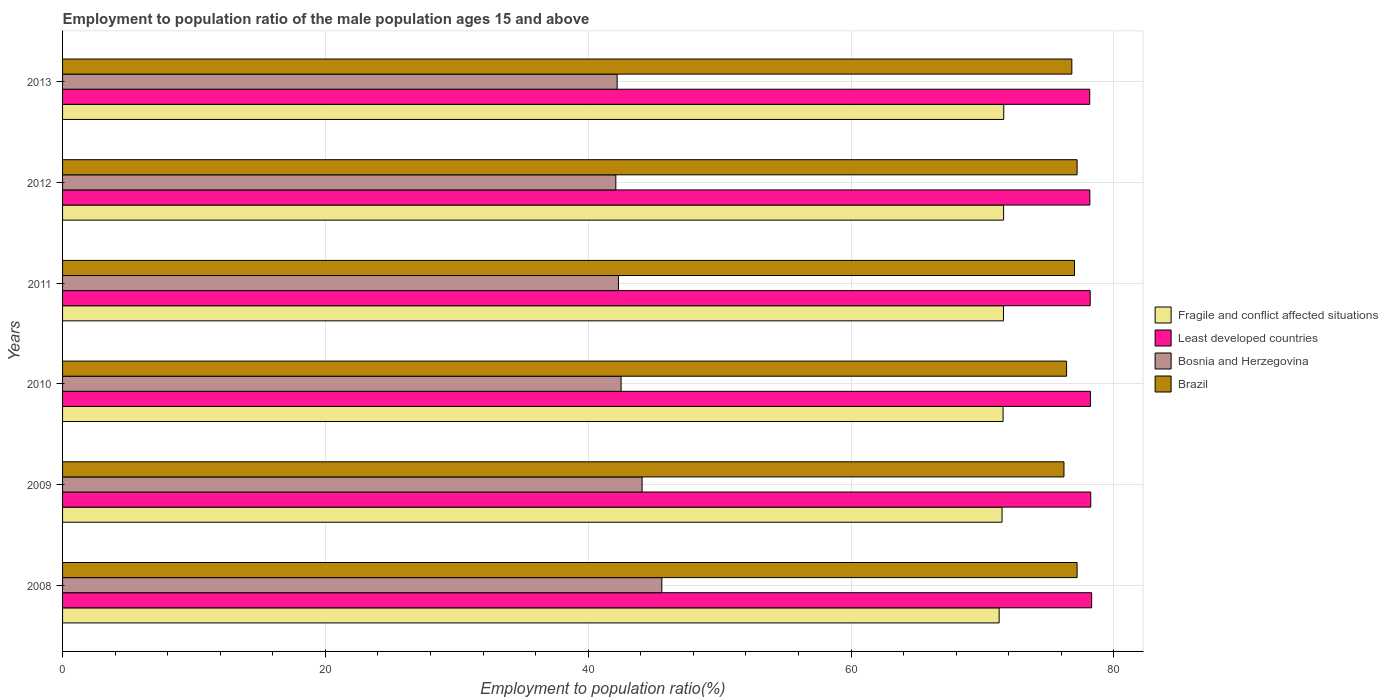How many groups of bars are there?
Provide a short and direct response. 6. Are the number of bars per tick equal to the number of legend labels?
Provide a short and direct response. Yes. Are the number of bars on each tick of the Y-axis equal?
Make the answer very short. Yes. What is the label of the 6th group of bars from the top?
Ensure brevity in your answer.  2008. What is the employment to population ratio in Bosnia and Herzegovina in 2012?
Your answer should be compact. 42.1. Across all years, what is the maximum employment to population ratio in Brazil?
Provide a short and direct response. 77.2. Across all years, what is the minimum employment to population ratio in Fragile and conflict affected situations?
Keep it short and to the point. 71.27. What is the total employment to population ratio in Fragile and conflict affected situations in the graph?
Ensure brevity in your answer.  429.14. What is the difference between the employment to population ratio in Least developed countries in 2011 and that in 2012?
Your answer should be compact. 0.03. What is the difference between the employment to population ratio in Bosnia and Herzegovina in 2010 and the employment to population ratio in Fragile and conflict affected situations in 2011?
Offer a very short reply. -29.1. What is the average employment to population ratio in Bosnia and Herzegovina per year?
Your response must be concise. 43.13. In the year 2013, what is the difference between the employment to population ratio in Brazil and employment to population ratio in Least developed countries?
Your answer should be very brief. -1.36. In how many years, is the employment to population ratio in Brazil greater than 44 %?
Your answer should be very brief. 6. What is the ratio of the employment to population ratio in Fragile and conflict affected situations in 2010 to that in 2012?
Offer a very short reply. 1. Is the employment to population ratio in Fragile and conflict affected situations in 2009 less than that in 2010?
Give a very brief answer. Yes. What is the difference between the highest and the second highest employment to population ratio in Brazil?
Ensure brevity in your answer.  0. Is it the case that in every year, the sum of the employment to population ratio in Brazil and employment to population ratio in Bosnia and Herzegovina is greater than the sum of employment to population ratio in Fragile and conflict affected situations and employment to population ratio in Least developed countries?
Your response must be concise. No. What does the 4th bar from the top in 2013 represents?
Ensure brevity in your answer.  Fragile and conflict affected situations. Is it the case that in every year, the sum of the employment to population ratio in Least developed countries and employment to population ratio in Brazil is greater than the employment to population ratio in Bosnia and Herzegovina?
Your answer should be very brief. Yes. How many bars are there?
Your response must be concise. 24. Are all the bars in the graph horizontal?
Ensure brevity in your answer.  Yes. How many years are there in the graph?
Give a very brief answer. 6. What is the difference between two consecutive major ticks on the X-axis?
Ensure brevity in your answer.  20. Are the values on the major ticks of X-axis written in scientific E-notation?
Provide a succinct answer. No. How many legend labels are there?
Your response must be concise. 4. How are the legend labels stacked?
Provide a short and direct response. Vertical. What is the title of the graph?
Give a very brief answer. Employment to population ratio of the male population ages 15 and above. What is the label or title of the X-axis?
Your answer should be very brief. Employment to population ratio(%). What is the label or title of the Y-axis?
Offer a very short reply. Years. What is the Employment to population ratio(%) of Fragile and conflict affected situations in 2008?
Your answer should be very brief. 71.27. What is the Employment to population ratio(%) of Least developed countries in 2008?
Your answer should be compact. 78.31. What is the Employment to population ratio(%) of Bosnia and Herzegovina in 2008?
Give a very brief answer. 45.6. What is the Employment to population ratio(%) in Brazil in 2008?
Make the answer very short. 77.2. What is the Employment to population ratio(%) of Fragile and conflict affected situations in 2009?
Keep it short and to the point. 71.49. What is the Employment to population ratio(%) in Least developed countries in 2009?
Provide a succinct answer. 78.24. What is the Employment to population ratio(%) of Bosnia and Herzegovina in 2009?
Provide a short and direct response. 44.1. What is the Employment to population ratio(%) of Brazil in 2009?
Give a very brief answer. 76.2. What is the Employment to population ratio(%) of Fragile and conflict affected situations in 2010?
Give a very brief answer. 71.57. What is the Employment to population ratio(%) in Least developed countries in 2010?
Provide a short and direct response. 78.22. What is the Employment to population ratio(%) in Bosnia and Herzegovina in 2010?
Ensure brevity in your answer.  42.5. What is the Employment to population ratio(%) of Brazil in 2010?
Offer a very short reply. 76.4. What is the Employment to population ratio(%) of Fragile and conflict affected situations in 2011?
Provide a succinct answer. 71.6. What is the Employment to population ratio(%) in Least developed countries in 2011?
Provide a short and direct response. 78.2. What is the Employment to population ratio(%) of Bosnia and Herzegovina in 2011?
Offer a very short reply. 42.3. What is the Employment to population ratio(%) in Brazil in 2011?
Provide a succinct answer. 77. What is the Employment to population ratio(%) of Fragile and conflict affected situations in 2012?
Provide a succinct answer. 71.61. What is the Employment to population ratio(%) of Least developed countries in 2012?
Provide a succinct answer. 78.17. What is the Employment to population ratio(%) of Bosnia and Herzegovina in 2012?
Provide a short and direct response. 42.1. What is the Employment to population ratio(%) in Brazil in 2012?
Provide a short and direct response. 77.2. What is the Employment to population ratio(%) of Fragile and conflict affected situations in 2013?
Offer a terse response. 71.62. What is the Employment to population ratio(%) of Least developed countries in 2013?
Provide a short and direct response. 78.16. What is the Employment to population ratio(%) of Bosnia and Herzegovina in 2013?
Your response must be concise. 42.2. What is the Employment to population ratio(%) of Brazil in 2013?
Ensure brevity in your answer.  76.8. Across all years, what is the maximum Employment to population ratio(%) in Fragile and conflict affected situations?
Provide a succinct answer. 71.62. Across all years, what is the maximum Employment to population ratio(%) of Least developed countries?
Ensure brevity in your answer.  78.31. Across all years, what is the maximum Employment to population ratio(%) in Bosnia and Herzegovina?
Offer a terse response. 45.6. Across all years, what is the maximum Employment to population ratio(%) of Brazil?
Give a very brief answer. 77.2. Across all years, what is the minimum Employment to population ratio(%) in Fragile and conflict affected situations?
Make the answer very short. 71.27. Across all years, what is the minimum Employment to population ratio(%) in Least developed countries?
Your answer should be very brief. 78.16. Across all years, what is the minimum Employment to population ratio(%) in Bosnia and Herzegovina?
Ensure brevity in your answer.  42.1. Across all years, what is the minimum Employment to population ratio(%) of Brazil?
Provide a short and direct response. 76.2. What is the total Employment to population ratio(%) in Fragile and conflict affected situations in the graph?
Provide a short and direct response. 429.14. What is the total Employment to population ratio(%) of Least developed countries in the graph?
Give a very brief answer. 469.29. What is the total Employment to population ratio(%) of Bosnia and Herzegovina in the graph?
Offer a very short reply. 258.8. What is the total Employment to population ratio(%) in Brazil in the graph?
Keep it short and to the point. 460.8. What is the difference between the Employment to population ratio(%) in Fragile and conflict affected situations in 2008 and that in 2009?
Provide a succinct answer. -0.22. What is the difference between the Employment to population ratio(%) in Least developed countries in 2008 and that in 2009?
Ensure brevity in your answer.  0.07. What is the difference between the Employment to population ratio(%) of Bosnia and Herzegovina in 2008 and that in 2009?
Offer a terse response. 1.5. What is the difference between the Employment to population ratio(%) in Brazil in 2008 and that in 2009?
Your answer should be very brief. 1. What is the difference between the Employment to population ratio(%) in Fragile and conflict affected situations in 2008 and that in 2010?
Your response must be concise. -0.3. What is the difference between the Employment to population ratio(%) in Least developed countries in 2008 and that in 2010?
Your answer should be very brief. 0.09. What is the difference between the Employment to population ratio(%) in Bosnia and Herzegovina in 2008 and that in 2010?
Offer a terse response. 3.1. What is the difference between the Employment to population ratio(%) of Brazil in 2008 and that in 2010?
Your answer should be compact. 0.8. What is the difference between the Employment to population ratio(%) in Fragile and conflict affected situations in 2008 and that in 2011?
Provide a succinct answer. -0.33. What is the difference between the Employment to population ratio(%) of Least developed countries in 2008 and that in 2011?
Your answer should be very brief. 0.11. What is the difference between the Employment to population ratio(%) of Brazil in 2008 and that in 2011?
Your response must be concise. 0.2. What is the difference between the Employment to population ratio(%) in Fragile and conflict affected situations in 2008 and that in 2012?
Ensure brevity in your answer.  -0.34. What is the difference between the Employment to population ratio(%) in Least developed countries in 2008 and that in 2012?
Ensure brevity in your answer.  0.14. What is the difference between the Employment to population ratio(%) of Bosnia and Herzegovina in 2008 and that in 2012?
Give a very brief answer. 3.5. What is the difference between the Employment to population ratio(%) in Brazil in 2008 and that in 2012?
Make the answer very short. 0. What is the difference between the Employment to population ratio(%) in Fragile and conflict affected situations in 2008 and that in 2013?
Ensure brevity in your answer.  -0.35. What is the difference between the Employment to population ratio(%) of Least developed countries in 2008 and that in 2013?
Give a very brief answer. 0.15. What is the difference between the Employment to population ratio(%) in Brazil in 2008 and that in 2013?
Your answer should be very brief. 0.4. What is the difference between the Employment to population ratio(%) in Fragile and conflict affected situations in 2009 and that in 2010?
Your answer should be compact. -0.08. What is the difference between the Employment to population ratio(%) of Least developed countries in 2009 and that in 2010?
Ensure brevity in your answer.  0.02. What is the difference between the Employment to population ratio(%) in Bosnia and Herzegovina in 2009 and that in 2010?
Your answer should be very brief. 1.6. What is the difference between the Employment to population ratio(%) of Fragile and conflict affected situations in 2009 and that in 2011?
Provide a short and direct response. -0.11. What is the difference between the Employment to population ratio(%) of Least developed countries in 2009 and that in 2011?
Provide a short and direct response. 0.04. What is the difference between the Employment to population ratio(%) of Bosnia and Herzegovina in 2009 and that in 2011?
Offer a very short reply. 1.8. What is the difference between the Employment to population ratio(%) in Fragile and conflict affected situations in 2009 and that in 2012?
Offer a very short reply. -0.12. What is the difference between the Employment to population ratio(%) in Least developed countries in 2009 and that in 2012?
Offer a terse response. 0.07. What is the difference between the Employment to population ratio(%) of Bosnia and Herzegovina in 2009 and that in 2012?
Make the answer very short. 2. What is the difference between the Employment to population ratio(%) of Fragile and conflict affected situations in 2009 and that in 2013?
Provide a succinct answer. -0.13. What is the difference between the Employment to population ratio(%) of Least developed countries in 2009 and that in 2013?
Give a very brief answer. 0.08. What is the difference between the Employment to population ratio(%) of Bosnia and Herzegovina in 2009 and that in 2013?
Offer a very short reply. 1.9. What is the difference between the Employment to population ratio(%) of Brazil in 2009 and that in 2013?
Make the answer very short. -0.6. What is the difference between the Employment to population ratio(%) in Fragile and conflict affected situations in 2010 and that in 2011?
Give a very brief answer. -0.03. What is the difference between the Employment to population ratio(%) of Least developed countries in 2010 and that in 2011?
Your answer should be very brief. 0.02. What is the difference between the Employment to population ratio(%) in Bosnia and Herzegovina in 2010 and that in 2011?
Ensure brevity in your answer.  0.2. What is the difference between the Employment to population ratio(%) of Brazil in 2010 and that in 2011?
Give a very brief answer. -0.6. What is the difference between the Employment to population ratio(%) of Fragile and conflict affected situations in 2010 and that in 2012?
Give a very brief answer. -0.04. What is the difference between the Employment to population ratio(%) in Least developed countries in 2010 and that in 2012?
Your answer should be very brief. 0.05. What is the difference between the Employment to population ratio(%) in Bosnia and Herzegovina in 2010 and that in 2012?
Your answer should be compact. 0.4. What is the difference between the Employment to population ratio(%) in Fragile and conflict affected situations in 2010 and that in 2013?
Your answer should be compact. -0.05. What is the difference between the Employment to population ratio(%) in Least developed countries in 2010 and that in 2013?
Provide a short and direct response. 0.06. What is the difference between the Employment to population ratio(%) in Bosnia and Herzegovina in 2010 and that in 2013?
Keep it short and to the point. 0.3. What is the difference between the Employment to population ratio(%) in Brazil in 2010 and that in 2013?
Give a very brief answer. -0.4. What is the difference between the Employment to population ratio(%) of Fragile and conflict affected situations in 2011 and that in 2012?
Offer a very short reply. -0.01. What is the difference between the Employment to population ratio(%) in Least developed countries in 2011 and that in 2012?
Your answer should be very brief. 0.03. What is the difference between the Employment to population ratio(%) of Bosnia and Herzegovina in 2011 and that in 2012?
Ensure brevity in your answer.  0.2. What is the difference between the Employment to population ratio(%) in Brazil in 2011 and that in 2012?
Ensure brevity in your answer.  -0.2. What is the difference between the Employment to population ratio(%) in Fragile and conflict affected situations in 2011 and that in 2013?
Provide a short and direct response. -0.02. What is the difference between the Employment to population ratio(%) of Least developed countries in 2011 and that in 2013?
Ensure brevity in your answer.  0.04. What is the difference between the Employment to population ratio(%) in Brazil in 2011 and that in 2013?
Provide a succinct answer. 0.2. What is the difference between the Employment to population ratio(%) in Fragile and conflict affected situations in 2012 and that in 2013?
Give a very brief answer. -0.01. What is the difference between the Employment to population ratio(%) of Least developed countries in 2012 and that in 2013?
Your answer should be very brief. 0.01. What is the difference between the Employment to population ratio(%) of Fragile and conflict affected situations in 2008 and the Employment to population ratio(%) of Least developed countries in 2009?
Keep it short and to the point. -6.97. What is the difference between the Employment to population ratio(%) of Fragile and conflict affected situations in 2008 and the Employment to population ratio(%) of Bosnia and Herzegovina in 2009?
Provide a succinct answer. 27.17. What is the difference between the Employment to population ratio(%) in Fragile and conflict affected situations in 2008 and the Employment to population ratio(%) in Brazil in 2009?
Your answer should be very brief. -4.93. What is the difference between the Employment to population ratio(%) of Least developed countries in 2008 and the Employment to population ratio(%) of Bosnia and Herzegovina in 2009?
Provide a succinct answer. 34.21. What is the difference between the Employment to population ratio(%) in Least developed countries in 2008 and the Employment to population ratio(%) in Brazil in 2009?
Keep it short and to the point. 2.11. What is the difference between the Employment to population ratio(%) of Bosnia and Herzegovina in 2008 and the Employment to population ratio(%) of Brazil in 2009?
Offer a terse response. -30.6. What is the difference between the Employment to population ratio(%) of Fragile and conflict affected situations in 2008 and the Employment to population ratio(%) of Least developed countries in 2010?
Keep it short and to the point. -6.95. What is the difference between the Employment to population ratio(%) in Fragile and conflict affected situations in 2008 and the Employment to population ratio(%) in Bosnia and Herzegovina in 2010?
Your response must be concise. 28.77. What is the difference between the Employment to population ratio(%) of Fragile and conflict affected situations in 2008 and the Employment to population ratio(%) of Brazil in 2010?
Your answer should be very brief. -5.13. What is the difference between the Employment to population ratio(%) of Least developed countries in 2008 and the Employment to population ratio(%) of Bosnia and Herzegovina in 2010?
Offer a terse response. 35.81. What is the difference between the Employment to population ratio(%) of Least developed countries in 2008 and the Employment to population ratio(%) of Brazil in 2010?
Your answer should be very brief. 1.91. What is the difference between the Employment to population ratio(%) in Bosnia and Herzegovina in 2008 and the Employment to population ratio(%) in Brazil in 2010?
Offer a terse response. -30.8. What is the difference between the Employment to population ratio(%) of Fragile and conflict affected situations in 2008 and the Employment to population ratio(%) of Least developed countries in 2011?
Keep it short and to the point. -6.93. What is the difference between the Employment to population ratio(%) in Fragile and conflict affected situations in 2008 and the Employment to population ratio(%) in Bosnia and Herzegovina in 2011?
Offer a terse response. 28.97. What is the difference between the Employment to population ratio(%) of Fragile and conflict affected situations in 2008 and the Employment to population ratio(%) of Brazil in 2011?
Keep it short and to the point. -5.73. What is the difference between the Employment to population ratio(%) of Least developed countries in 2008 and the Employment to population ratio(%) of Bosnia and Herzegovina in 2011?
Your response must be concise. 36.01. What is the difference between the Employment to population ratio(%) of Least developed countries in 2008 and the Employment to population ratio(%) of Brazil in 2011?
Your answer should be compact. 1.31. What is the difference between the Employment to population ratio(%) in Bosnia and Herzegovina in 2008 and the Employment to population ratio(%) in Brazil in 2011?
Make the answer very short. -31.4. What is the difference between the Employment to population ratio(%) of Fragile and conflict affected situations in 2008 and the Employment to population ratio(%) of Least developed countries in 2012?
Your answer should be very brief. -6.9. What is the difference between the Employment to population ratio(%) in Fragile and conflict affected situations in 2008 and the Employment to population ratio(%) in Bosnia and Herzegovina in 2012?
Offer a very short reply. 29.17. What is the difference between the Employment to population ratio(%) of Fragile and conflict affected situations in 2008 and the Employment to population ratio(%) of Brazil in 2012?
Ensure brevity in your answer.  -5.93. What is the difference between the Employment to population ratio(%) in Least developed countries in 2008 and the Employment to population ratio(%) in Bosnia and Herzegovina in 2012?
Provide a succinct answer. 36.21. What is the difference between the Employment to population ratio(%) of Least developed countries in 2008 and the Employment to population ratio(%) of Brazil in 2012?
Make the answer very short. 1.11. What is the difference between the Employment to population ratio(%) of Bosnia and Herzegovina in 2008 and the Employment to population ratio(%) of Brazil in 2012?
Provide a short and direct response. -31.6. What is the difference between the Employment to population ratio(%) of Fragile and conflict affected situations in 2008 and the Employment to population ratio(%) of Least developed countries in 2013?
Your answer should be very brief. -6.89. What is the difference between the Employment to population ratio(%) of Fragile and conflict affected situations in 2008 and the Employment to population ratio(%) of Bosnia and Herzegovina in 2013?
Provide a short and direct response. 29.07. What is the difference between the Employment to population ratio(%) of Fragile and conflict affected situations in 2008 and the Employment to population ratio(%) of Brazil in 2013?
Offer a terse response. -5.53. What is the difference between the Employment to population ratio(%) of Least developed countries in 2008 and the Employment to population ratio(%) of Bosnia and Herzegovina in 2013?
Your response must be concise. 36.11. What is the difference between the Employment to population ratio(%) in Least developed countries in 2008 and the Employment to population ratio(%) in Brazil in 2013?
Keep it short and to the point. 1.51. What is the difference between the Employment to population ratio(%) of Bosnia and Herzegovina in 2008 and the Employment to population ratio(%) of Brazil in 2013?
Offer a very short reply. -31.2. What is the difference between the Employment to population ratio(%) in Fragile and conflict affected situations in 2009 and the Employment to population ratio(%) in Least developed countries in 2010?
Your answer should be very brief. -6.73. What is the difference between the Employment to population ratio(%) of Fragile and conflict affected situations in 2009 and the Employment to population ratio(%) of Bosnia and Herzegovina in 2010?
Provide a short and direct response. 28.99. What is the difference between the Employment to population ratio(%) in Fragile and conflict affected situations in 2009 and the Employment to population ratio(%) in Brazil in 2010?
Your response must be concise. -4.91. What is the difference between the Employment to population ratio(%) in Least developed countries in 2009 and the Employment to population ratio(%) in Bosnia and Herzegovina in 2010?
Provide a short and direct response. 35.74. What is the difference between the Employment to population ratio(%) of Least developed countries in 2009 and the Employment to population ratio(%) of Brazil in 2010?
Offer a very short reply. 1.84. What is the difference between the Employment to population ratio(%) in Bosnia and Herzegovina in 2009 and the Employment to population ratio(%) in Brazil in 2010?
Your response must be concise. -32.3. What is the difference between the Employment to population ratio(%) of Fragile and conflict affected situations in 2009 and the Employment to population ratio(%) of Least developed countries in 2011?
Make the answer very short. -6.71. What is the difference between the Employment to population ratio(%) of Fragile and conflict affected situations in 2009 and the Employment to population ratio(%) of Bosnia and Herzegovina in 2011?
Your answer should be very brief. 29.19. What is the difference between the Employment to population ratio(%) in Fragile and conflict affected situations in 2009 and the Employment to population ratio(%) in Brazil in 2011?
Offer a very short reply. -5.51. What is the difference between the Employment to population ratio(%) of Least developed countries in 2009 and the Employment to population ratio(%) of Bosnia and Herzegovina in 2011?
Make the answer very short. 35.94. What is the difference between the Employment to population ratio(%) in Least developed countries in 2009 and the Employment to population ratio(%) in Brazil in 2011?
Offer a very short reply. 1.24. What is the difference between the Employment to population ratio(%) of Bosnia and Herzegovina in 2009 and the Employment to population ratio(%) of Brazil in 2011?
Give a very brief answer. -32.9. What is the difference between the Employment to population ratio(%) of Fragile and conflict affected situations in 2009 and the Employment to population ratio(%) of Least developed countries in 2012?
Ensure brevity in your answer.  -6.68. What is the difference between the Employment to population ratio(%) of Fragile and conflict affected situations in 2009 and the Employment to population ratio(%) of Bosnia and Herzegovina in 2012?
Make the answer very short. 29.39. What is the difference between the Employment to population ratio(%) of Fragile and conflict affected situations in 2009 and the Employment to population ratio(%) of Brazil in 2012?
Make the answer very short. -5.71. What is the difference between the Employment to population ratio(%) of Least developed countries in 2009 and the Employment to population ratio(%) of Bosnia and Herzegovina in 2012?
Offer a terse response. 36.14. What is the difference between the Employment to population ratio(%) of Least developed countries in 2009 and the Employment to population ratio(%) of Brazil in 2012?
Keep it short and to the point. 1.04. What is the difference between the Employment to population ratio(%) in Bosnia and Herzegovina in 2009 and the Employment to population ratio(%) in Brazil in 2012?
Make the answer very short. -33.1. What is the difference between the Employment to population ratio(%) in Fragile and conflict affected situations in 2009 and the Employment to population ratio(%) in Least developed countries in 2013?
Provide a succinct answer. -6.67. What is the difference between the Employment to population ratio(%) of Fragile and conflict affected situations in 2009 and the Employment to population ratio(%) of Bosnia and Herzegovina in 2013?
Offer a terse response. 29.29. What is the difference between the Employment to population ratio(%) in Fragile and conflict affected situations in 2009 and the Employment to population ratio(%) in Brazil in 2013?
Your answer should be very brief. -5.31. What is the difference between the Employment to population ratio(%) of Least developed countries in 2009 and the Employment to population ratio(%) of Bosnia and Herzegovina in 2013?
Ensure brevity in your answer.  36.04. What is the difference between the Employment to population ratio(%) in Least developed countries in 2009 and the Employment to population ratio(%) in Brazil in 2013?
Your answer should be very brief. 1.44. What is the difference between the Employment to population ratio(%) in Bosnia and Herzegovina in 2009 and the Employment to population ratio(%) in Brazil in 2013?
Make the answer very short. -32.7. What is the difference between the Employment to population ratio(%) in Fragile and conflict affected situations in 2010 and the Employment to population ratio(%) in Least developed countries in 2011?
Make the answer very short. -6.63. What is the difference between the Employment to population ratio(%) in Fragile and conflict affected situations in 2010 and the Employment to population ratio(%) in Bosnia and Herzegovina in 2011?
Your answer should be compact. 29.27. What is the difference between the Employment to population ratio(%) in Fragile and conflict affected situations in 2010 and the Employment to population ratio(%) in Brazil in 2011?
Make the answer very short. -5.43. What is the difference between the Employment to population ratio(%) in Least developed countries in 2010 and the Employment to population ratio(%) in Bosnia and Herzegovina in 2011?
Offer a very short reply. 35.92. What is the difference between the Employment to population ratio(%) in Least developed countries in 2010 and the Employment to population ratio(%) in Brazil in 2011?
Your answer should be compact. 1.22. What is the difference between the Employment to population ratio(%) in Bosnia and Herzegovina in 2010 and the Employment to population ratio(%) in Brazil in 2011?
Provide a succinct answer. -34.5. What is the difference between the Employment to population ratio(%) of Fragile and conflict affected situations in 2010 and the Employment to population ratio(%) of Least developed countries in 2012?
Provide a short and direct response. -6.6. What is the difference between the Employment to population ratio(%) of Fragile and conflict affected situations in 2010 and the Employment to population ratio(%) of Bosnia and Herzegovina in 2012?
Your answer should be very brief. 29.47. What is the difference between the Employment to population ratio(%) of Fragile and conflict affected situations in 2010 and the Employment to population ratio(%) of Brazil in 2012?
Keep it short and to the point. -5.63. What is the difference between the Employment to population ratio(%) in Least developed countries in 2010 and the Employment to population ratio(%) in Bosnia and Herzegovina in 2012?
Provide a succinct answer. 36.12. What is the difference between the Employment to population ratio(%) in Least developed countries in 2010 and the Employment to population ratio(%) in Brazil in 2012?
Make the answer very short. 1.02. What is the difference between the Employment to population ratio(%) in Bosnia and Herzegovina in 2010 and the Employment to population ratio(%) in Brazil in 2012?
Keep it short and to the point. -34.7. What is the difference between the Employment to population ratio(%) of Fragile and conflict affected situations in 2010 and the Employment to population ratio(%) of Least developed countries in 2013?
Offer a very short reply. -6.59. What is the difference between the Employment to population ratio(%) in Fragile and conflict affected situations in 2010 and the Employment to population ratio(%) in Bosnia and Herzegovina in 2013?
Ensure brevity in your answer.  29.37. What is the difference between the Employment to population ratio(%) of Fragile and conflict affected situations in 2010 and the Employment to population ratio(%) of Brazil in 2013?
Make the answer very short. -5.23. What is the difference between the Employment to population ratio(%) of Least developed countries in 2010 and the Employment to population ratio(%) of Bosnia and Herzegovina in 2013?
Offer a terse response. 36.02. What is the difference between the Employment to population ratio(%) in Least developed countries in 2010 and the Employment to population ratio(%) in Brazil in 2013?
Your answer should be compact. 1.42. What is the difference between the Employment to population ratio(%) of Bosnia and Herzegovina in 2010 and the Employment to population ratio(%) of Brazil in 2013?
Your response must be concise. -34.3. What is the difference between the Employment to population ratio(%) in Fragile and conflict affected situations in 2011 and the Employment to population ratio(%) in Least developed countries in 2012?
Offer a very short reply. -6.57. What is the difference between the Employment to population ratio(%) of Fragile and conflict affected situations in 2011 and the Employment to population ratio(%) of Bosnia and Herzegovina in 2012?
Offer a very short reply. 29.5. What is the difference between the Employment to population ratio(%) in Fragile and conflict affected situations in 2011 and the Employment to population ratio(%) in Brazil in 2012?
Your response must be concise. -5.6. What is the difference between the Employment to population ratio(%) of Least developed countries in 2011 and the Employment to population ratio(%) of Bosnia and Herzegovina in 2012?
Offer a terse response. 36.1. What is the difference between the Employment to population ratio(%) of Bosnia and Herzegovina in 2011 and the Employment to population ratio(%) of Brazil in 2012?
Offer a very short reply. -34.9. What is the difference between the Employment to population ratio(%) of Fragile and conflict affected situations in 2011 and the Employment to population ratio(%) of Least developed countries in 2013?
Offer a very short reply. -6.56. What is the difference between the Employment to population ratio(%) in Fragile and conflict affected situations in 2011 and the Employment to population ratio(%) in Bosnia and Herzegovina in 2013?
Your answer should be very brief. 29.4. What is the difference between the Employment to population ratio(%) of Fragile and conflict affected situations in 2011 and the Employment to population ratio(%) of Brazil in 2013?
Keep it short and to the point. -5.2. What is the difference between the Employment to population ratio(%) in Least developed countries in 2011 and the Employment to population ratio(%) in Bosnia and Herzegovina in 2013?
Your answer should be very brief. 36. What is the difference between the Employment to population ratio(%) of Least developed countries in 2011 and the Employment to population ratio(%) of Brazil in 2013?
Give a very brief answer. 1.4. What is the difference between the Employment to population ratio(%) in Bosnia and Herzegovina in 2011 and the Employment to population ratio(%) in Brazil in 2013?
Make the answer very short. -34.5. What is the difference between the Employment to population ratio(%) in Fragile and conflict affected situations in 2012 and the Employment to population ratio(%) in Least developed countries in 2013?
Provide a succinct answer. -6.55. What is the difference between the Employment to population ratio(%) in Fragile and conflict affected situations in 2012 and the Employment to population ratio(%) in Bosnia and Herzegovina in 2013?
Your answer should be very brief. 29.41. What is the difference between the Employment to population ratio(%) of Fragile and conflict affected situations in 2012 and the Employment to population ratio(%) of Brazil in 2013?
Your answer should be compact. -5.19. What is the difference between the Employment to population ratio(%) in Least developed countries in 2012 and the Employment to population ratio(%) in Bosnia and Herzegovina in 2013?
Provide a short and direct response. 35.97. What is the difference between the Employment to population ratio(%) in Least developed countries in 2012 and the Employment to population ratio(%) in Brazil in 2013?
Ensure brevity in your answer.  1.37. What is the difference between the Employment to population ratio(%) of Bosnia and Herzegovina in 2012 and the Employment to population ratio(%) of Brazil in 2013?
Ensure brevity in your answer.  -34.7. What is the average Employment to population ratio(%) in Fragile and conflict affected situations per year?
Give a very brief answer. 71.52. What is the average Employment to population ratio(%) in Least developed countries per year?
Keep it short and to the point. 78.21. What is the average Employment to population ratio(%) of Bosnia and Herzegovina per year?
Your answer should be very brief. 43.13. What is the average Employment to population ratio(%) of Brazil per year?
Keep it short and to the point. 76.8. In the year 2008, what is the difference between the Employment to population ratio(%) in Fragile and conflict affected situations and Employment to population ratio(%) in Least developed countries?
Make the answer very short. -7.04. In the year 2008, what is the difference between the Employment to population ratio(%) in Fragile and conflict affected situations and Employment to population ratio(%) in Bosnia and Herzegovina?
Provide a short and direct response. 25.67. In the year 2008, what is the difference between the Employment to population ratio(%) of Fragile and conflict affected situations and Employment to population ratio(%) of Brazil?
Keep it short and to the point. -5.93. In the year 2008, what is the difference between the Employment to population ratio(%) in Least developed countries and Employment to population ratio(%) in Bosnia and Herzegovina?
Provide a short and direct response. 32.71. In the year 2008, what is the difference between the Employment to population ratio(%) in Least developed countries and Employment to population ratio(%) in Brazil?
Give a very brief answer. 1.11. In the year 2008, what is the difference between the Employment to population ratio(%) of Bosnia and Herzegovina and Employment to population ratio(%) of Brazil?
Offer a very short reply. -31.6. In the year 2009, what is the difference between the Employment to population ratio(%) of Fragile and conflict affected situations and Employment to population ratio(%) of Least developed countries?
Your answer should be compact. -6.75. In the year 2009, what is the difference between the Employment to population ratio(%) of Fragile and conflict affected situations and Employment to population ratio(%) of Bosnia and Herzegovina?
Give a very brief answer. 27.39. In the year 2009, what is the difference between the Employment to population ratio(%) of Fragile and conflict affected situations and Employment to population ratio(%) of Brazil?
Offer a very short reply. -4.71. In the year 2009, what is the difference between the Employment to population ratio(%) in Least developed countries and Employment to population ratio(%) in Bosnia and Herzegovina?
Provide a short and direct response. 34.14. In the year 2009, what is the difference between the Employment to population ratio(%) in Least developed countries and Employment to population ratio(%) in Brazil?
Your answer should be compact. 2.04. In the year 2009, what is the difference between the Employment to population ratio(%) of Bosnia and Herzegovina and Employment to population ratio(%) of Brazil?
Provide a succinct answer. -32.1. In the year 2010, what is the difference between the Employment to population ratio(%) in Fragile and conflict affected situations and Employment to population ratio(%) in Least developed countries?
Provide a succinct answer. -6.65. In the year 2010, what is the difference between the Employment to population ratio(%) in Fragile and conflict affected situations and Employment to population ratio(%) in Bosnia and Herzegovina?
Make the answer very short. 29.07. In the year 2010, what is the difference between the Employment to population ratio(%) in Fragile and conflict affected situations and Employment to population ratio(%) in Brazil?
Your answer should be compact. -4.83. In the year 2010, what is the difference between the Employment to population ratio(%) in Least developed countries and Employment to population ratio(%) in Bosnia and Herzegovina?
Keep it short and to the point. 35.72. In the year 2010, what is the difference between the Employment to population ratio(%) of Least developed countries and Employment to population ratio(%) of Brazil?
Your answer should be compact. 1.82. In the year 2010, what is the difference between the Employment to population ratio(%) of Bosnia and Herzegovina and Employment to population ratio(%) of Brazil?
Your answer should be compact. -33.9. In the year 2011, what is the difference between the Employment to population ratio(%) of Fragile and conflict affected situations and Employment to population ratio(%) of Least developed countries?
Give a very brief answer. -6.6. In the year 2011, what is the difference between the Employment to population ratio(%) of Fragile and conflict affected situations and Employment to population ratio(%) of Bosnia and Herzegovina?
Offer a terse response. 29.3. In the year 2011, what is the difference between the Employment to population ratio(%) in Fragile and conflict affected situations and Employment to population ratio(%) in Brazil?
Provide a short and direct response. -5.4. In the year 2011, what is the difference between the Employment to population ratio(%) in Least developed countries and Employment to population ratio(%) in Bosnia and Herzegovina?
Your answer should be very brief. 35.9. In the year 2011, what is the difference between the Employment to population ratio(%) in Least developed countries and Employment to population ratio(%) in Brazil?
Offer a very short reply. 1.2. In the year 2011, what is the difference between the Employment to population ratio(%) of Bosnia and Herzegovina and Employment to population ratio(%) of Brazil?
Provide a succinct answer. -34.7. In the year 2012, what is the difference between the Employment to population ratio(%) of Fragile and conflict affected situations and Employment to population ratio(%) of Least developed countries?
Provide a short and direct response. -6.56. In the year 2012, what is the difference between the Employment to population ratio(%) of Fragile and conflict affected situations and Employment to population ratio(%) of Bosnia and Herzegovina?
Make the answer very short. 29.51. In the year 2012, what is the difference between the Employment to population ratio(%) of Fragile and conflict affected situations and Employment to population ratio(%) of Brazil?
Your response must be concise. -5.59. In the year 2012, what is the difference between the Employment to population ratio(%) of Least developed countries and Employment to population ratio(%) of Bosnia and Herzegovina?
Offer a very short reply. 36.07. In the year 2012, what is the difference between the Employment to population ratio(%) in Least developed countries and Employment to population ratio(%) in Brazil?
Keep it short and to the point. 0.97. In the year 2012, what is the difference between the Employment to population ratio(%) of Bosnia and Herzegovina and Employment to population ratio(%) of Brazil?
Your answer should be very brief. -35.1. In the year 2013, what is the difference between the Employment to population ratio(%) in Fragile and conflict affected situations and Employment to population ratio(%) in Least developed countries?
Ensure brevity in your answer.  -6.54. In the year 2013, what is the difference between the Employment to population ratio(%) in Fragile and conflict affected situations and Employment to population ratio(%) in Bosnia and Herzegovina?
Provide a short and direct response. 29.42. In the year 2013, what is the difference between the Employment to population ratio(%) of Fragile and conflict affected situations and Employment to population ratio(%) of Brazil?
Make the answer very short. -5.18. In the year 2013, what is the difference between the Employment to population ratio(%) in Least developed countries and Employment to population ratio(%) in Bosnia and Herzegovina?
Provide a succinct answer. 35.96. In the year 2013, what is the difference between the Employment to population ratio(%) in Least developed countries and Employment to population ratio(%) in Brazil?
Provide a short and direct response. 1.36. In the year 2013, what is the difference between the Employment to population ratio(%) of Bosnia and Herzegovina and Employment to population ratio(%) of Brazil?
Offer a terse response. -34.6. What is the ratio of the Employment to population ratio(%) in Least developed countries in 2008 to that in 2009?
Ensure brevity in your answer.  1. What is the ratio of the Employment to population ratio(%) of Bosnia and Herzegovina in 2008 to that in 2009?
Provide a short and direct response. 1.03. What is the ratio of the Employment to population ratio(%) in Brazil in 2008 to that in 2009?
Your response must be concise. 1.01. What is the ratio of the Employment to population ratio(%) of Bosnia and Herzegovina in 2008 to that in 2010?
Offer a terse response. 1.07. What is the ratio of the Employment to population ratio(%) of Brazil in 2008 to that in 2010?
Offer a terse response. 1.01. What is the ratio of the Employment to population ratio(%) of Fragile and conflict affected situations in 2008 to that in 2011?
Offer a very short reply. 1. What is the ratio of the Employment to population ratio(%) in Least developed countries in 2008 to that in 2011?
Your answer should be very brief. 1. What is the ratio of the Employment to population ratio(%) in Bosnia and Herzegovina in 2008 to that in 2011?
Give a very brief answer. 1.08. What is the ratio of the Employment to population ratio(%) of Least developed countries in 2008 to that in 2012?
Your answer should be very brief. 1. What is the ratio of the Employment to population ratio(%) of Bosnia and Herzegovina in 2008 to that in 2012?
Your answer should be very brief. 1.08. What is the ratio of the Employment to population ratio(%) of Brazil in 2008 to that in 2012?
Ensure brevity in your answer.  1. What is the ratio of the Employment to population ratio(%) in Fragile and conflict affected situations in 2008 to that in 2013?
Your answer should be compact. 1. What is the ratio of the Employment to population ratio(%) of Bosnia and Herzegovina in 2008 to that in 2013?
Your answer should be very brief. 1.08. What is the ratio of the Employment to population ratio(%) in Least developed countries in 2009 to that in 2010?
Offer a terse response. 1. What is the ratio of the Employment to population ratio(%) in Bosnia and Herzegovina in 2009 to that in 2010?
Your answer should be very brief. 1.04. What is the ratio of the Employment to population ratio(%) in Fragile and conflict affected situations in 2009 to that in 2011?
Provide a short and direct response. 1. What is the ratio of the Employment to population ratio(%) in Bosnia and Herzegovina in 2009 to that in 2011?
Make the answer very short. 1.04. What is the ratio of the Employment to population ratio(%) of Brazil in 2009 to that in 2011?
Offer a very short reply. 0.99. What is the ratio of the Employment to population ratio(%) of Fragile and conflict affected situations in 2009 to that in 2012?
Offer a very short reply. 1. What is the ratio of the Employment to population ratio(%) of Bosnia and Herzegovina in 2009 to that in 2012?
Provide a short and direct response. 1.05. What is the ratio of the Employment to population ratio(%) of Fragile and conflict affected situations in 2009 to that in 2013?
Give a very brief answer. 1. What is the ratio of the Employment to population ratio(%) of Bosnia and Herzegovina in 2009 to that in 2013?
Offer a terse response. 1.04. What is the ratio of the Employment to population ratio(%) of Least developed countries in 2010 to that in 2011?
Offer a very short reply. 1. What is the ratio of the Employment to population ratio(%) in Bosnia and Herzegovina in 2010 to that in 2011?
Provide a short and direct response. 1. What is the ratio of the Employment to population ratio(%) in Brazil in 2010 to that in 2011?
Your response must be concise. 0.99. What is the ratio of the Employment to population ratio(%) of Least developed countries in 2010 to that in 2012?
Ensure brevity in your answer.  1. What is the ratio of the Employment to population ratio(%) in Bosnia and Herzegovina in 2010 to that in 2012?
Offer a very short reply. 1.01. What is the ratio of the Employment to population ratio(%) in Fragile and conflict affected situations in 2010 to that in 2013?
Your response must be concise. 1. What is the ratio of the Employment to population ratio(%) in Least developed countries in 2010 to that in 2013?
Ensure brevity in your answer.  1. What is the ratio of the Employment to population ratio(%) of Bosnia and Herzegovina in 2010 to that in 2013?
Make the answer very short. 1.01. What is the ratio of the Employment to population ratio(%) in Brazil in 2010 to that in 2013?
Your answer should be compact. 0.99. What is the ratio of the Employment to population ratio(%) in Fragile and conflict affected situations in 2011 to that in 2012?
Ensure brevity in your answer.  1. What is the ratio of the Employment to population ratio(%) of Least developed countries in 2011 to that in 2012?
Give a very brief answer. 1. What is the ratio of the Employment to population ratio(%) of Brazil in 2011 to that in 2012?
Offer a terse response. 1. What is the ratio of the Employment to population ratio(%) in Fragile and conflict affected situations in 2011 to that in 2013?
Your response must be concise. 1. What is the ratio of the Employment to population ratio(%) in Least developed countries in 2011 to that in 2013?
Your response must be concise. 1. What is the ratio of the Employment to population ratio(%) in Bosnia and Herzegovina in 2011 to that in 2013?
Provide a short and direct response. 1. What is the ratio of the Employment to population ratio(%) of Brazil in 2011 to that in 2013?
Keep it short and to the point. 1. What is the ratio of the Employment to population ratio(%) of Brazil in 2012 to that in 2013?
Give a very brief answer. 1.01. What is the difference between the highest and the second highest Employment to population ratio(%) in Fragile and conflict affected situations?
Make the answer very short. 0.01. What is the difference between the highest and the second highest Employment to population ratio(%) in Least developed countries?
Offer a terse response. 0.07. What is the difference between the highest and the second highest Employment to population ratio(%) in Bosnia and Herzegovina?
Give a very brief answer. 1.5. What is the difference between the highest and the second highest Employment to population ratio(%) of Brazil?
Give a very brief answer. 0. What is the difference between the highest and the lowest Employment to population ratio(%) in Fragile and conflict affected situations?
Your answer should be very brief. 0.35. What is the difference between the highest and the lowest Employment to population ratio(%) of Least developed countries?
Provide a short and direct response. 0.15. 